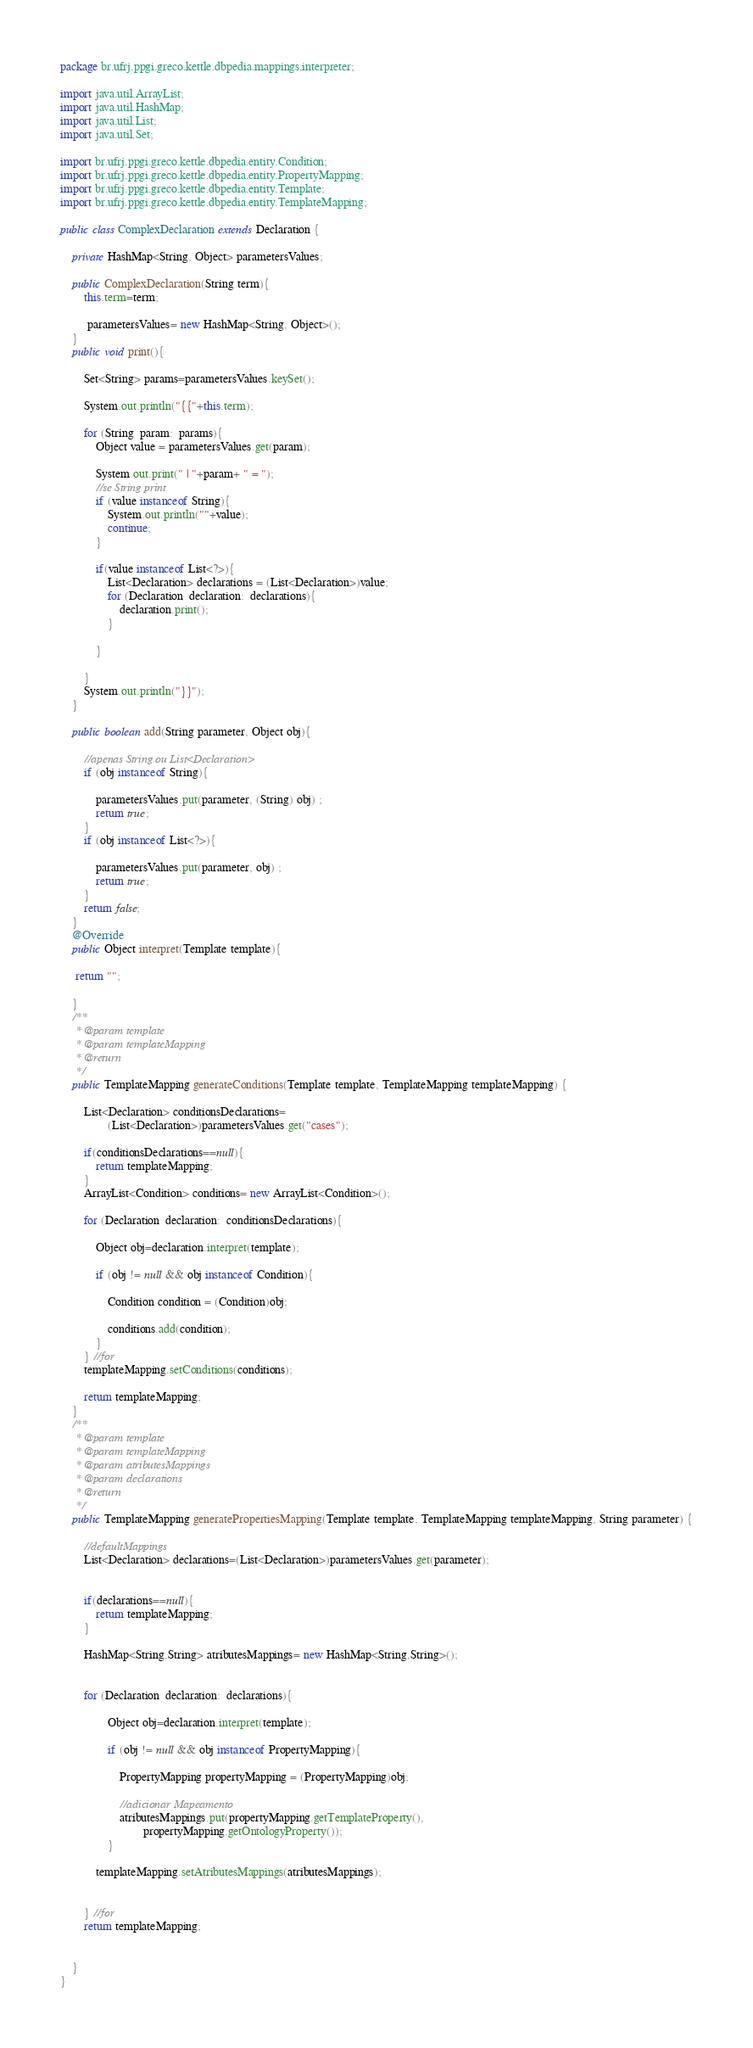<code> <loc_0><loc_0><loc_500><loc_500><_Java_>package br.ufrj.ppgi.greco.kettle.dbpedia.mappings.interpreter;

import java.util.ArrayList;
import java.util.HashMap;
import java.util.List;
import java.util.Set;

import br.ufrj.ppgi.greco.kettle.dbpedia.entity.Condition;
import br.ufrj.ppgi.greco.kettle.dbpedia.entity.PropertyMapping;
import br.ufrj.ppgi.greco.kettle.dbpedia.entity.Template;
import br.ufrj.ppgi.greco.kettle.dbpedia.entity.TemplateMapping;

public class ComplexDeclaration extends Declaration {

	private HashMap<String, Object> parametersValues;
	
	public ComplexDeclaration(String term){
		this.term=term;
		
		 parametersValues= new HashMap<String, Object>(); 
	}
	public void print(){
		
		Set<String> params=parametersValues.keySet();
		
		System.out.println("{{"+this.term);
		
		for (String  param:  params){
			Object value = parametersValues.get(param);
			
			System.out.print(" | "+param+ " = ");
			//se String print
			if (value instanceof String){
				System.out.println(""+value);
				continue;
			}
			
			if(value instanceof List<?>){
				List<Declaration> declarations = (List<Declaration>)value;
				for (Declaration  declaration:  declarations){
					declaration.print();
				}
							
			}
			
		}
		System.out.println("}}");
	}
	
	public boolean add(String parameter, Object obj){
		
		//apenas String ou List<Declaration>
		if (obj instanceof String){
			
			parametersValues.put(parameter, (String) obj) ;
			return true;
		}
		if (obj instanceof List<?>){
			
			parametersValues.put(parameter, obj) ;
			return true;
		}
		return false;
	}
	@Override
	public Object interpret(Template template){
		
	 return "";
		
	}
	/**
	 * @param template
	 * @param templateMapping
	 * @return 
	 */
	public TemplateMapping generateConditions(Template template, TemplateMapping templateMapping) {
		
		List<Declaration> conditionsDeclarations=
				(List<Declaration>)parametersValues.get("cases");
		
		if(conditionsDeclarations==null){
			return templateMapping;
		}
		ArrayList<Condition> conditions= new ArrayList<Condition>();
		
		for (Declaration  declaration:  conditionsDeclarations){
			
			Object obj=declaration.interpret(template);
			
			if (obj != null && obj instanceof Condition){
				
				Condition condition = (Condition)obj;
				
				conditions.add(condition);
			}		
		} //for
		templateMapping.setConditions(conditions);
		
		return templateMapping;
	}
	/**
	 * @param template
	 * @param templateMapping
	 * @param atributesMappings
	 * @param declarations
	 * @return 
	 */
	public TemplateMapping generatePropertiesMapping(Template template, TemplateMapping templateMapping, String parameter) {
		
		//defaultMappings
		List<Declaration> declarations=(List<Declaration>)parametersValues.get(parameter);
		
		
		if(declarations==null){
			return templateMapping;
		}
		
		HashMap<String,String> atributesMappings= new HashMap<String,String>();
		
			
		for (Declaration  declaration:  declarations){
				
				Object obj=declaration.interpret(template);
				
				if (obj != null && obj instanceof PropertyMapping){
					
					PropertyMapping propertyMapping = (PropertyMapping)obj;
					
					//adicionar Mapeamento
					atributesMappings.put(propertyMapping.getTemplateProperty(), 
							propertyMapping.getOntologyProperty());
				}
					
			templateMapping.setAtributesMappings(atributesMappings);
			
			
		} //for
		return templateMapping;
		
		
	}
}
</code> 